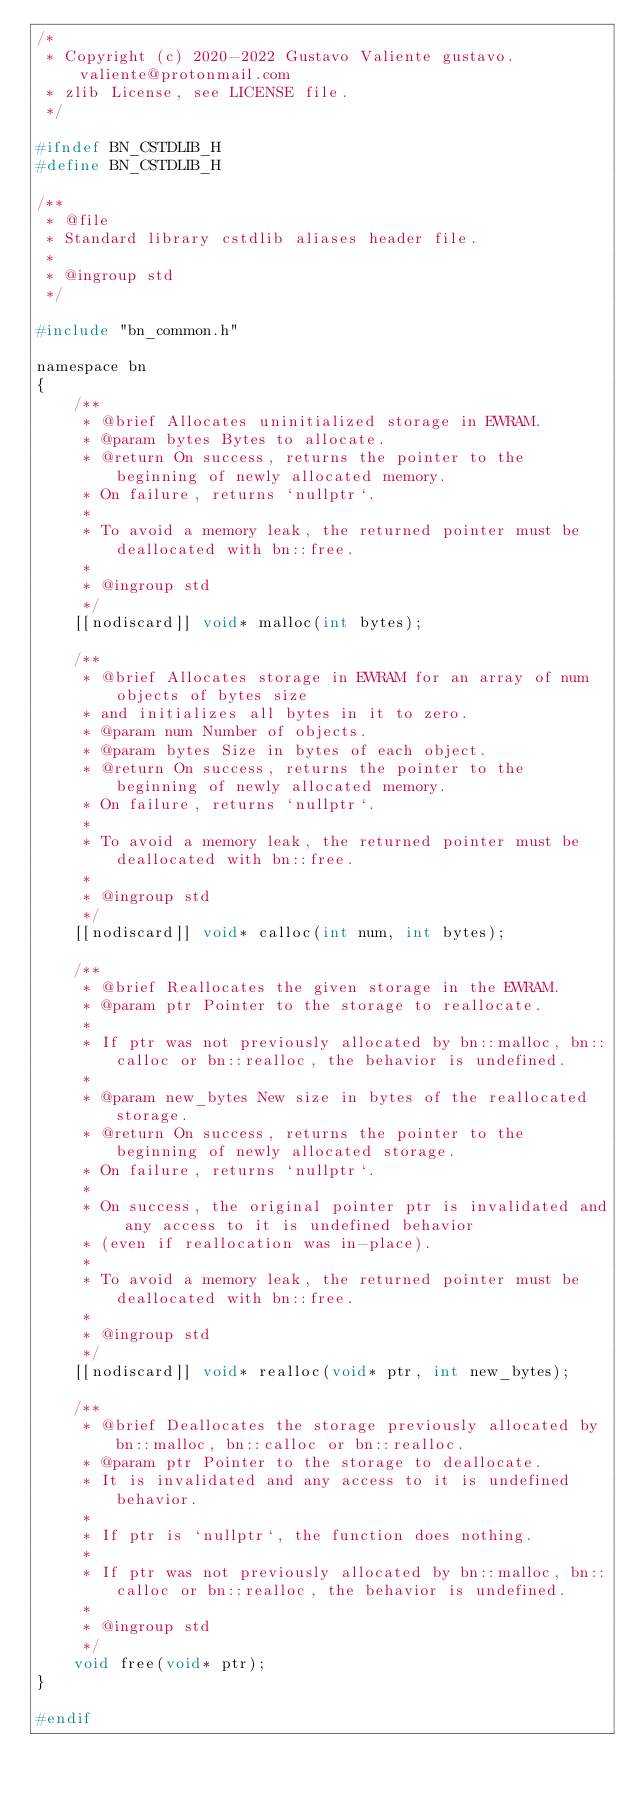<code> <loc_0><loc_0><loc_500><loc_500><_C_>/*
 * Copyright (c) 2020-2022 Gustavo Valiente gustavo.valiente@protonmail.com
 * zlib License, see LICENSE file.
 */

#ifndef BN_CSTDLIB_H
#define BN_CSTDLIB_H

/**
 * @file
 * Standard library cstdlib aliases header file.
 *
 * @ingroup std
 */

#include "bn_common.h"

namespace bn
{
    /**
     * @brief Allocates uninitialized storage in EWRAM.
     * @param bytes Bytes to allocate.
     * @return On success, returns the pointer to the beginning of newly allocated memory.
     * On failure, returns `nullptr`.
     *
     * To avoid a memory leak, the returned pointer must be deallocated with bn::free.
     *
     * @ingroup std
     */
    [[nodiscard]] void* malloc(int bytes);

    /**
     * @brief Allocates storage in EWRAM for an array of num objects of bytes size
     * and initializes all bytes in it to zero.
     * @param num Number of objects.
     * @param bytes Size in bytes of each object.
     * @return On success, returns the pointer to the beginning of newly allocated memory.
     * On failure, returns `nullptr`.
     *
     * To avoid a memory leak, the returned pointer must be deallocated with bn::free.
     *
     * @ingroup std
     */
    [[nodiscard]] void* calloc(int num, int bytes);

    /**
     * @brief Reallocates the given storage in the EWRAM.
     * @param ptr Pointer to the storage to reallocate.
     *
     * If ptr was not previously allocated by bn::malloc, bn::calloc or bn::realloc, the behavior is undefined.
     *
     * @param new_bytes New size in bytes of the reallocated storage.
     * @return On success, returns the pointer to the beginning of newly allocated storage.
     * On failure, returns `nullptr`.
     *
     * On success, the original pointer ptr is invalidated and any access to it is undefined behavior
     * (even if reallocation was in-place).
     *
     * To avoid a memory leak, the returned pointer must be deallocated with bn::free.
     *
     * @ingroup std
     */
    [[nodiscard]] void* realloc(void* ptr, int new_bytes);

    /**
     * @brief Deallocates the storage previously allocated by bn::malloc, bn::calloc or bn::realloc.
     * @param ptr Pointer to the storage to deallocate.
     * It is invalidated and any access to it is undefined behavior.
     *
     * If ptr is `nullptr`, the function does nothing.
     *
     * If ptr was not previously allocated by bn::malloc, bn::calloc or bn::realloc, the behavior is undefined.
     *
     * @ingroup std
     */
    void free(void* ptr);
}

#endif
</code> 